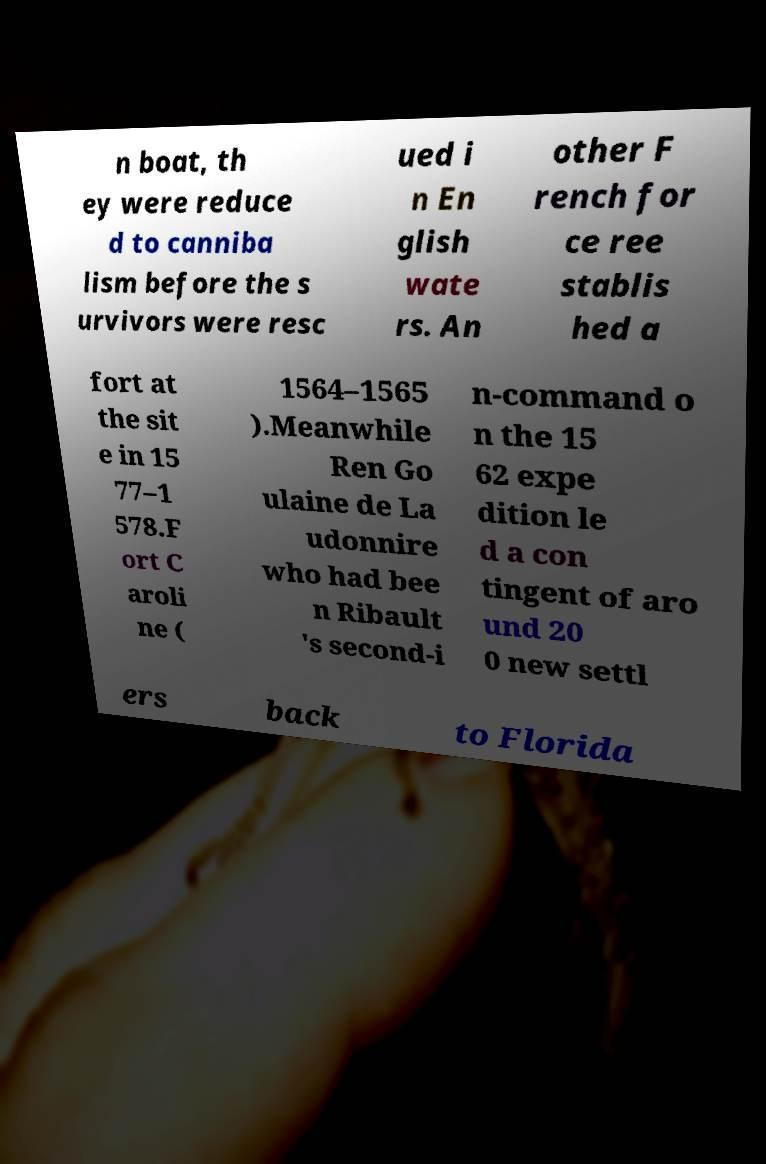Please read and relay the text visible in this image. What does it say? n boat, th ey were reduce d to canniba lism before the s urvivors were resc ued i n En glish wate rs. An other F rench for ce ree stablis hed a fort at the sit e in 15 77–1 578.F ort C aroli ne ( 1564–1565 ).Meanwhile Ren Go ulaine de La udonnire who had bee n Ribault 's second-i n-command o n the 15 62 expe dition le d a con tingent of aro und 20 0 new settl ers back to Florida 